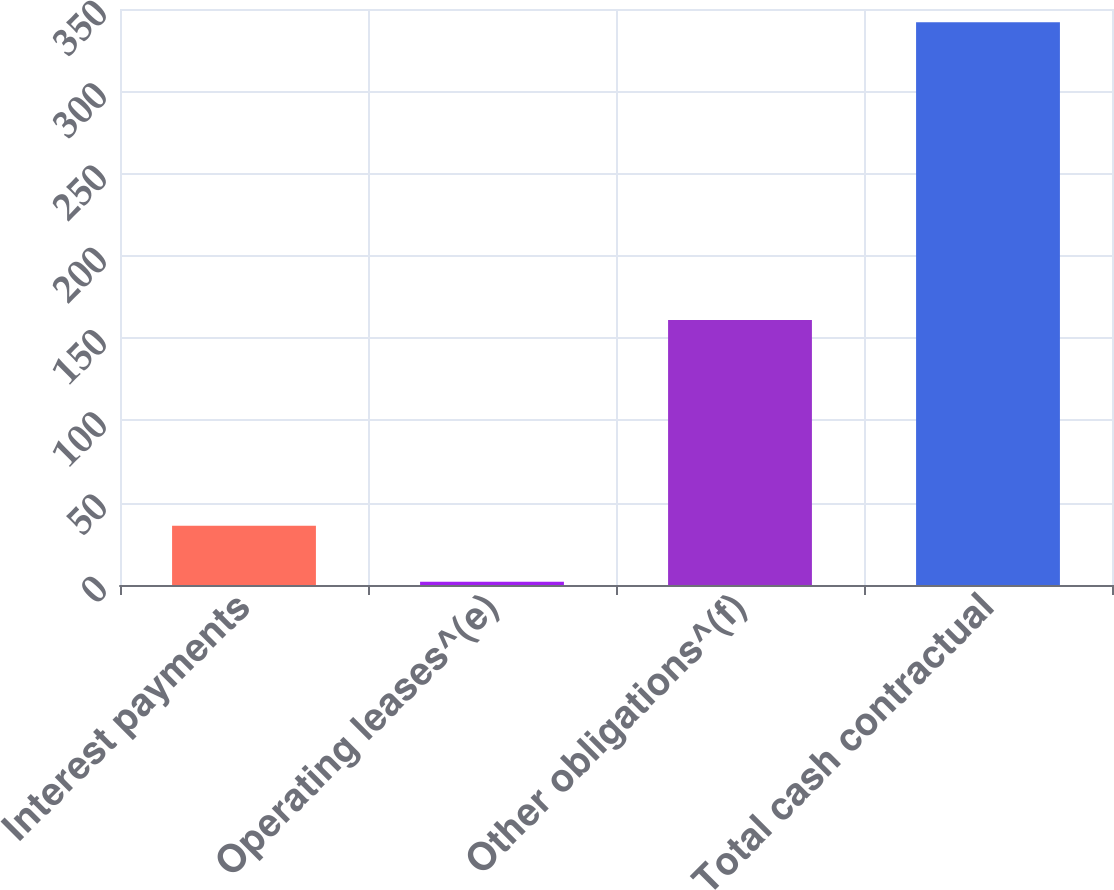Convert chart. <chart><loc_0><loc_0><loc_500><loc_500><bar_chart><fcel>Interest payments<fcel>Operating leases^(e)<fcel>Other obligations^(f)<fcel>Total cash contractual<nl><fcel>36<fcel>2<fcel>161<fcel>342<nl></chart> 